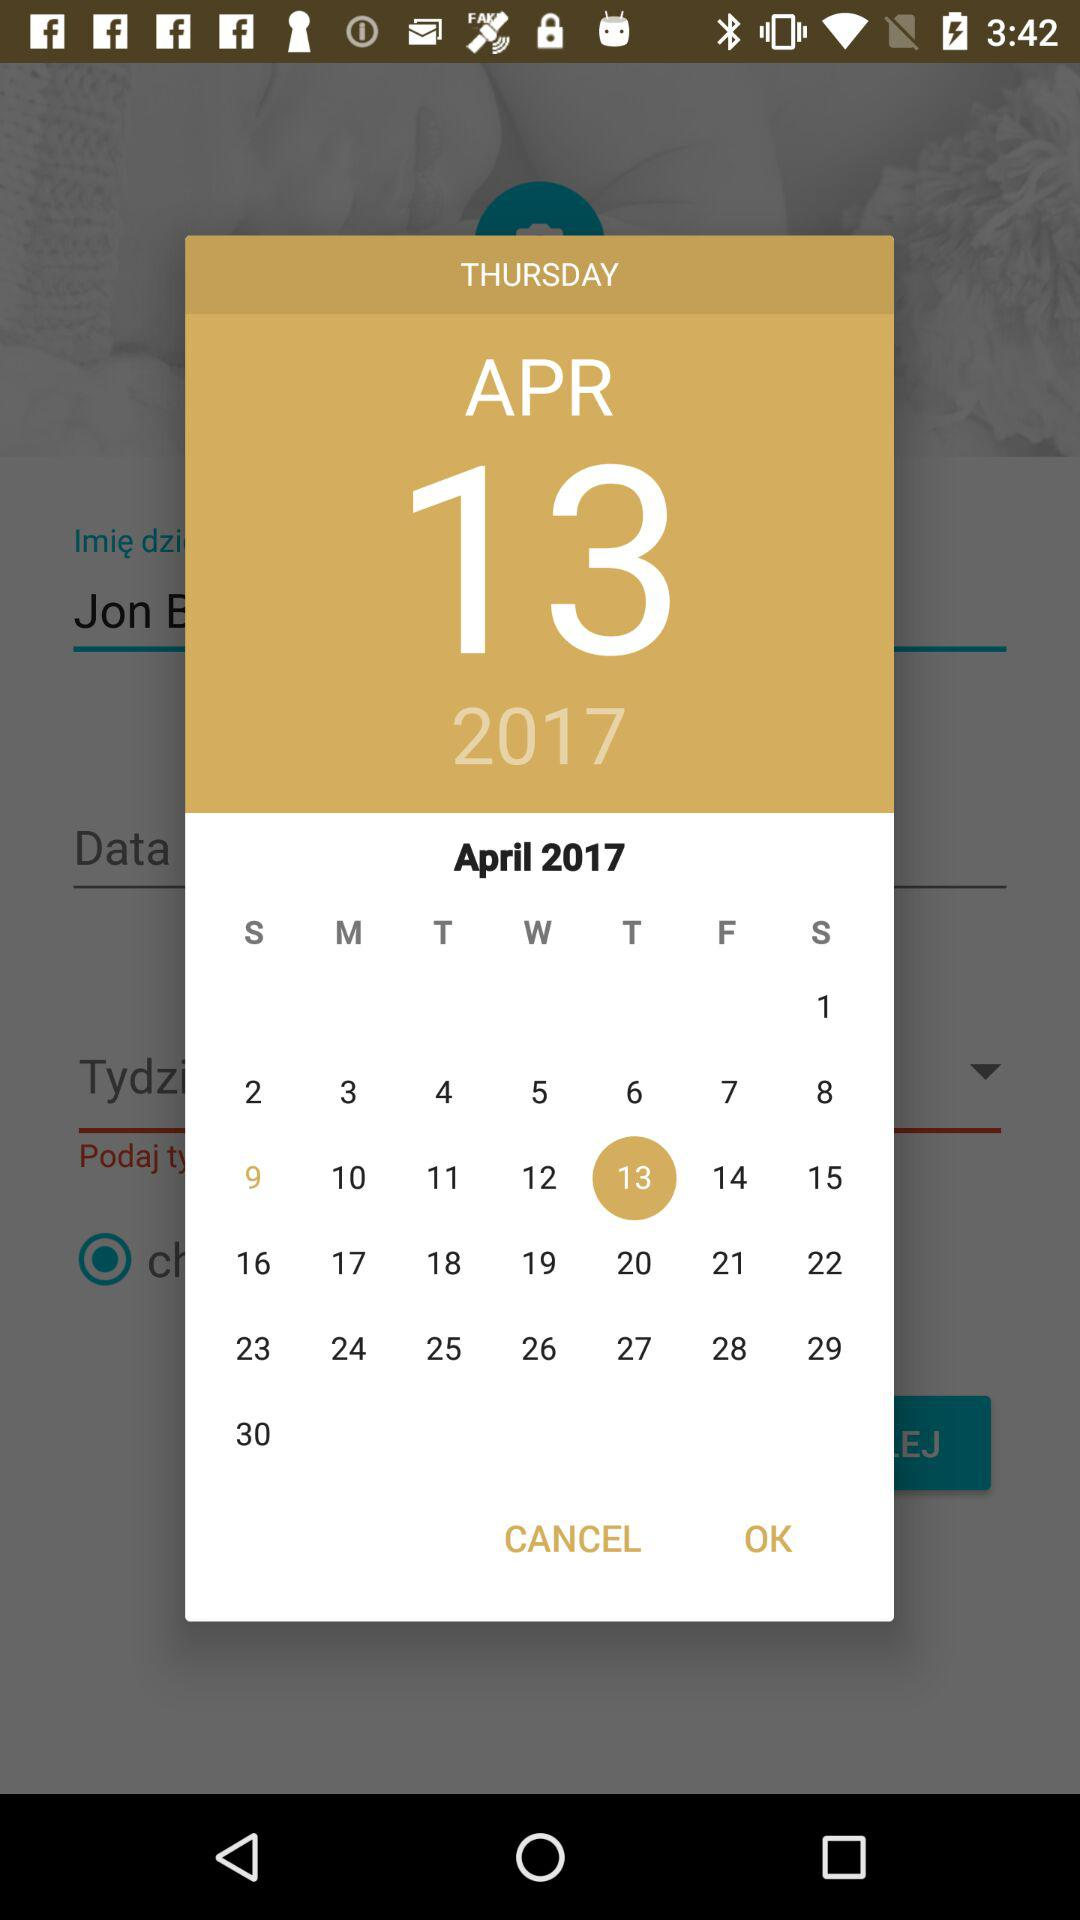What date is selected? The selected date is Thursday, April 13, 2017. 